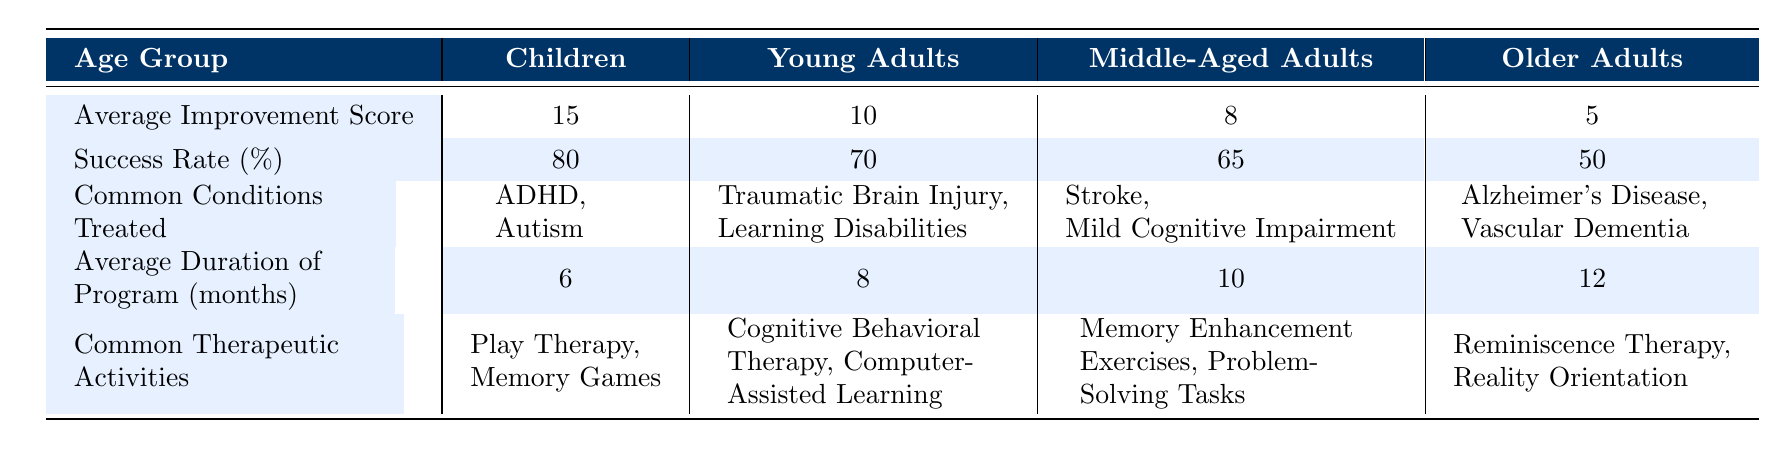What is the average improvement score for children? The table indicates that the average improvement score for the Children age group is 15.
Answer: 15 What is the success rate percentage for older adults? According to the table, the success rate percentage for the Older Adults age group is 50%.
Answer: 50% Which age group has the highest average improvement score? The highest average improvement score is found in the Children age group with a score of 15.
Answer: Children What are the common therapeutic activities listed for middle-aged adults? The table shows that the common therapeutic activities for Middle-Aged Adults are Memory Enhancement Exercises and Problem-Solving Tasks.
Answer: Memory Enhancement Exercises, Problem-Solving Tasks What is the average duration of the cognitive rehabilitation program for young adults? The table states that the average duration of the program for Young Adults is 8 months.
Answer: 8 months Is the success rate for young adults higher than that for middle-aged adults? The success rate for Young Adults is 70%, while for Middle-Aged Adults, it is 65%, indicating that young adults have a higher success rate.
Answer: Yes What is the difference in the average improvement score between children and older adults? The average improvement score for Children is 15 and for Older Adults, it is 5. The difference is 15 - 5 = 10.
Answer: 10 If we were to average the program durations across all age groups, what would that be? Adding the average durations: 6 (Children) + 8 (Young Adults) + 10 (Middle-Aged Adults) + 12 (Older Adults) = 36 months. There are 4 age groups, so the average duration is 36/4 = 9 months.
Answer: 9 months Are Alzheimer’s Disease and Vascular Dementia common conditions treated for children? The table indicates that these conditions are treated for Older Adults, not Children, making this statement false.
Answer: No What is the success rate percentage for children compared to older adults? The success rate percentage for Children is 80%, while for Older Adults, it is 50%, showing that Children have a significantly higher success rate by 30 percentage points.
Answer: 30 percentage points higher 